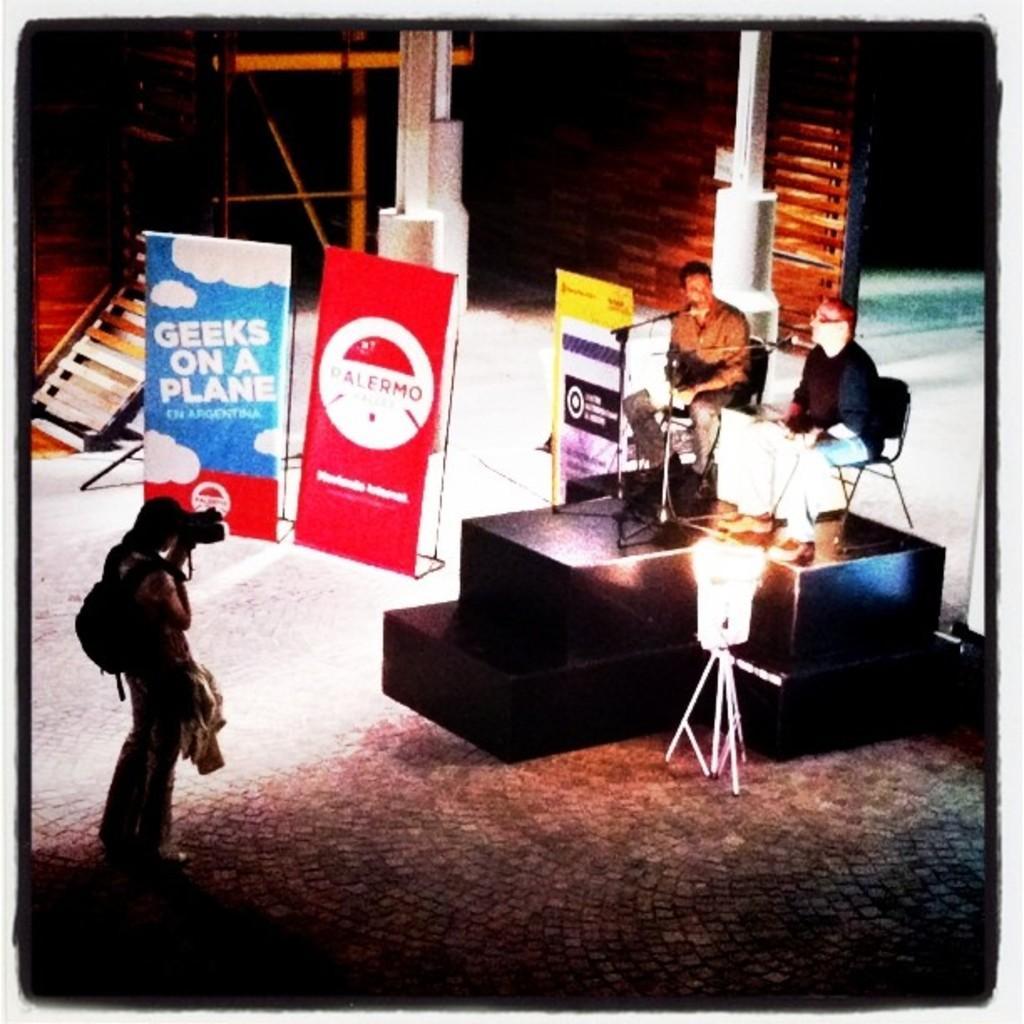Could you give a brief overview of what you see in this image? In this picture we can find three persons, two persons are sitting on a chairs near the microphone on the stage and one person is standing on the floor with a camera capturing them. In the background we can find a wooden wall, steps, and a stand. 